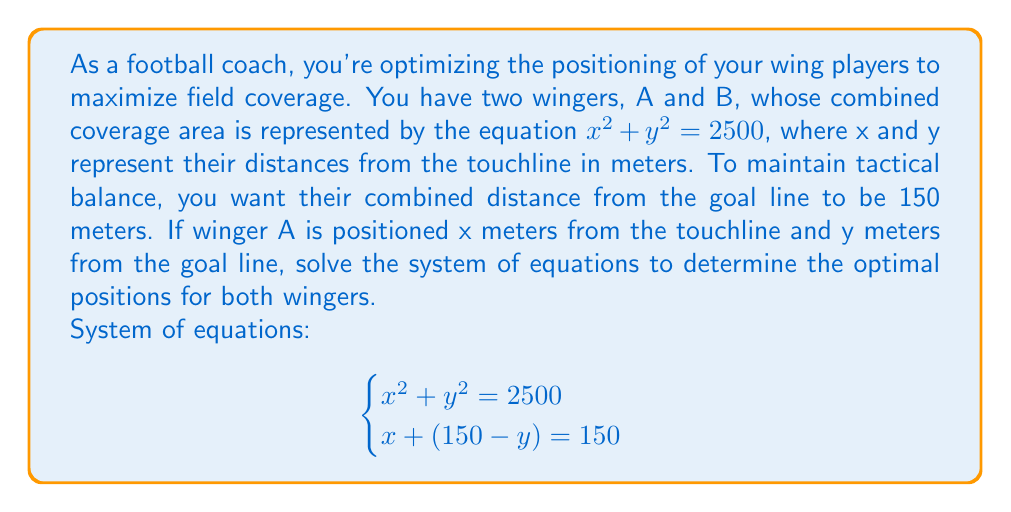Solve this math problem. Let's solve this system of equations step by step:

1) From the second equation, we can express x in terms of y:
   $x + (150 - y) = 150$
   $x = y$

2) Substitute this into the first equation:
   $x^2 + y^2 = 2500$
   $y^2 + y^2 = 2500$
   $2y^2 = 2500$

3) Solve for y:
   $y^2 = 1250$
   $y = \sqrt{1250} = 25\sqrt{2} \approx 35.36$

4) Since $x = y$, we now know both coordinates:
   $x = y = 25\sqrt{2}$

5) To find winger B's position, recall that their combined distance from the goal line is 150 meters. So B's distance from the goal line is:
   $150 - y = 150 - 25\sqrt{2} \approx 114.64$

Therefore, the optimal positions are:
Winger A: $(25\sqrt{2}, 25\sqrt{2})$ meters from (touchline, goal line)
Winger B: $(25\sqrt{2}, 150 - 25\sqrt{2})$ meters from (touchline, goal line)
Answer: Winger A: $(25\sqrt{2}, 25\sqrt{2})$, Winger B: $(25\sqrt{2}, 150 - 25\sqrt{2})$ 